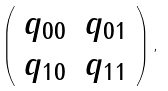Convert formula to latex. <formula><loc_0><loc_0><loc_500><loc_500>\left ( \begin{array} { c c } q _ { 0 0 } & q _ { 0 1 } \\ q _ { 1 0 } & q _ { 1 1 } \end{array} \right ) ,</formula> 